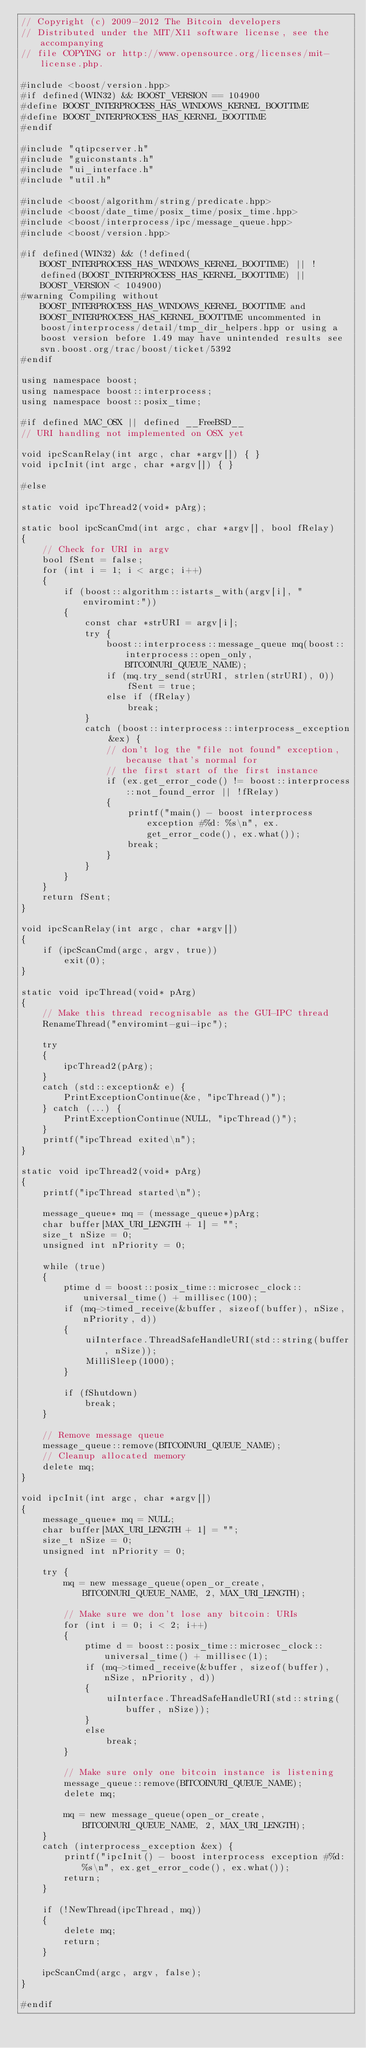Convert code to text. <code><loc_0><loc_0><loc_500><loc_500><_C++_>// Copyright (c) 2009-2012 The Bitcoin developers
// Distributed under the MIT/X11 software license, see the accompanying
// file COPYING or http://www.opensource.org/licenses/mit-license.php.

#include <boost/version.hpp>
#if defined(WIN32) && BOOST_VERSION == 104900
#define BOOST_INTERPROCESS_HAS_WINDOWS_KERNEL_BOOTTIME
#define BOOST_INTERPROCESS_HAS_KERNEL_BOOTTIME
#endif

#include "qtipcserver.h"
#include "guiconstants.h"
#include "ui_interface.h"
#include "util.h"

#include <boost/algorithm/string/predicate.hpp>
#include <boost/date_time/posix_time/posix_time.hpp>
#include <boost/interprocess/ipc/message_queue.hpp>
#include <boost/version.hpp>

#if defined(WIN32) && (!defined(BOOST_INTERPROCESS_HAS_WINDOWS_KERNEL_BOOTTIME) || !defined(BOOST_INTERPROCESS_HAS_KERNEL_BOOTTIME) || BOOST_VERSION < 104900)
#warning Compiling without BOOST_INTERPROCESS_HAS_WINDOWS_KERNEL_BOOTTIME and BOOST_INTERPROCESS_HAS_KERNEL_BOOTTIME uncommented in boost/interprocess/detail/tmp_dir_helpers.hpp or using a boost version before 1.49 may have unintended results see svn.boost.org/trac/boost/ticket/5392
#endif

using namespace boost;
using namespace boost::interprocess;
using namespace boost::posix_time;

#if defined MAC_OSX || defined __FreeBSD__
// URI handling not implemented on OSX yet

void ipcScanRelay(int argc, char *argv[]) { }
void ipcInit(int argc, char *argv[]) { }

#else

static void ipcThread2(void* pArg);

static bool ipcScanCmd(int argc, char *argv[], bool fRelay)
{
    // Check for URI in argv
    bool fSent = false;
    for (int i = 1; i < argc; i++)
    {
        if (boost::algorithm::istarts_with(argv[i], "enviromint:"))
        {
            const char *strURI = argv[i];
            try {
                boost::interprocess::message_queue mq(boost::interprocess::open_only, BITCOINURI_QUEUE_NAME);
                if (mq.try_send(strURI, strlen(strURI), 0))
                    fSent = true;
                else if (fRelay)
                    break;
            }
            catch (boost::interprocess::interprocess_exception &ex) {
                // don't log the "file not found" exception, because that's normal for
                // the first start of the first instance
                if (ex.get_error_code() != boost::interprocess::not_found_error || !fRelay)
                {
                    printf("main() - boost interprocess exception #%d: %s\n", ex.get_error_code(), ex.what());
                    break;
                }
            }
        }
    }
    return fSent;
}

void ipcScanRelay(int argc, char *argv[])
{
    if (ipcScanCmd(argc, argv, true))
        exit(0);
}

static void ipcThread(void* pArg)
{
    // Make this thread recognisable as the GUI-IPC thread
    RenameThread("enviromint-gui-ipc");
	
    try
    {
        ipcThread2(pArg);
    }
    catch (std::exception& e) {
        PrintExceptionContinue(&e, "ipcThread()");
    } catch (...) {
        PrintExceptionContinue(NULL, "ipcThread()");
    }
    printf("ipcThread exited\n");
}

static void ipcThread2(void* pArg)
{
    printf("ipcThread started\n");

    message_queue* mq = (message_queue*)pArg;
    char buffer[MAX_URI_LENGTH + 1] = "";
    size_t nSize = 0;
    unsigned int nPriority = 0;

    while (true)
    {
        ptime d = boost::posix_time::microsec_clock::universal_time() + millisec(100);
        if (mq->timed_receive(&buffer, sizeof(buffer), nSize, nPriority, d))
        {
            uiInterface.ThreadSafeHandleURI(std::string(buffer, nSize));
            MilliSleep(1000);
        }

        if (fShutdown)
            break;
    }

    // Remove message queue
    message_queue::remove(BITCOINURI_QUEUE_NAME);
    // Cleanup allocated memory
    delete mq;
}

void ipcInit(int argc, char *argv[])
{
    message_queue* mq = NULL;
    char buffer[MAX_URI_LENGTH + 1] = "";
    size_t nSize = 0;
    unsigned int nPriority = 0;

    try {
        mq = new message_queue(open_or_create, BITCOINURI_QUEUE_NAME, 2, MAX_URI_LENGTH);

        // Make sure we don't lose any bitcoin: URIs
        for (int i = 0; i < 2; i++)
        {
            ptime d = boost::posix_time::microsec_clock::universal_time() + millisec(1);
            if (mq->timed_receive(&buffer, sizeof(buffer), nSize, nPriority, d))
            {
                uiInterface.ThreadSafeHandleURI(std::string(buffer, nSize));
            }
            else
                break;
        }

        // Make sure only one bitcoin instance is listening
        message_queue::remove(BITCOINURI_QUEUE_NAME);
        delete mq;

        mq = new message_queue(open_or_create, BITCOINURI_QUEUE_NAME, 2, MAX_URI_LENGTH);
    }
    catch (interprocess_exception &ex) {
        printf("ipcInit() - boost interprocess exception #%d: %s\n", ex.get_error_code(), ex.what());
        return;
    }

    if (!NewThread(ipcThread, mq))
    {
        delete mq;
        return;
    }

    ipcScanCmd(argc, argv, false);
}

#endif
</code> 